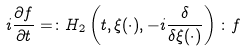Convert formula to latex. <formula><loc_0><loc_0><loc_500><loc_500>i \frac { \partial f } { \partial t } = \colon H _ { 2 } \left ( t , \xi ( \cdot ) , - i \frac { \delta } { \delta \xi ( \cdot ) } \right ) \colon f</formula> 